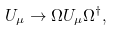<formula> <loc_0><loc_0><loc_500><loc_500>U _ { \mu } \to \Omega U _ { \mu } \Omega ^ { \dagger } ,</formula> 